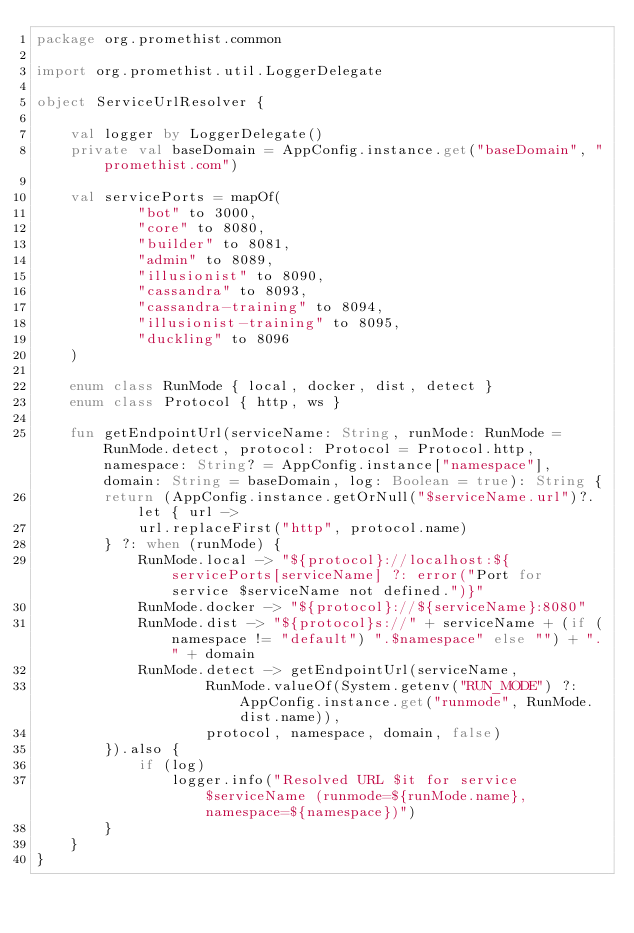<code> <loc_0><loc_0><loc_500><loc_500><_Kotlin_>package org.promethist.common

import org.promethist.util.LoggerDelegate

object ServiceUrlResolver {

    val logger by LoggerDelegate()
    private val baseDomain = AppConfig.instance.get("baseDomain", "promethist.com")

    val servicePorts = mapOf(
            "bot" to 3000,
            "core" to 8080,
            "builder" to 8081,
            "admin" to 8089,
            "illusionist" to 8090,
            "cassandra" to 8093,
            "cassandra-training" to 8094,
            "illusionist-training" to 8095,
            "duckling" to 8096
    )

    enum class RunMode { local, docker, dist, detect }
    enum class Protocol { http, ws }

    fun getEndpointUrl(serviceName: String, runMode: RunMode = RunMode.detect, protocol: Protocol = Protocol.http, namespace: String? = AppConfig.instance["namespace"], domain: String = baseDomain, log: Boolean = true): String {
        return (AppConfig.instance.getOrNull("$serviceName.url")?.let { url ->
            url.replaceFirst("http", protocol.name)
        } ?: when (runMode) {
            RunMode.local -> "${protocol}://localhost:${servicePorts[serviceName] ?: error("Port for service $serviceName not defined.")}"
            RunMode.docker -> "${protocol}://${serviceName}:8080"
            RunMode.dist -> "${protocol}s://" + serviceName + (if (namespace != "default") ".$namespace" else "") + "." + domain
            RunMode.detect -> getEndpointUrl(serviceName,
                    RunMode.valueOf(System.getenv("RUN_MODE") ?: AppConfig.instance.get("runmode", RunMode.dist.name)),
                    protocol, namespace, domain, false)
        }).also {
            if (log)
                logger.info("Resolved URL $it for service $serviceName (runmode=${runMode.name}, namespace=${namespace})")
        }
    }
}</code> 